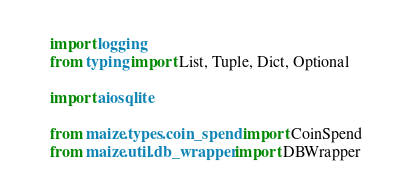Convert code to text. <code><loc_0><loc_0><loc_500><loc_500><_Python_>import logging
from typing import List, Tuple, Dict, Optional

import aiosqlite

from maize.types.coin_spend import CoinSpend
from maize.util.db_wrapper import DBWrapper</code> 